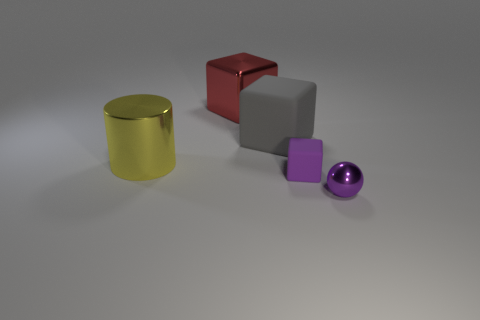What shape is the thing that is behind the gray matte block that is to the left of the small purple thing behind the purple shiny object?
Give a very brief answer. Cube. There is a tiny rubber thing; does it have the same shape as the large metallic object behind the gray matte object?
Provide a short and direct response. Yes. What number of tiny things are balls or brown matte spheres?
Ensure brevity in your answer.  1. Are there any purple cubes that have the same size as the purple shiny object?
Your response must be concise. Yes. What color is the big block that is right of the large block that is behind the big cube in front of the big red thing?
Give a very brief answer. Gray. Does the big gray cube have the same material as the big object that is to the left of the large red metal block?
Keep it short and to the point. No. What is the size of the other rubber object that is the same shape as the tiny purple matte thing?
Your answer should be compact. Large. Are there the same number of big shiny cylinders in front of the small block and objects behind the large yellow metal object?
Give a very brief answer. No. How many other things are there of the same material as the tiny ball?
Your response must be concise. 2. Are there an equal number of tiny purple rubber cubes to the left of the yellow cylinder and small blue rubber things?
Your answer should be compact. Yes. 